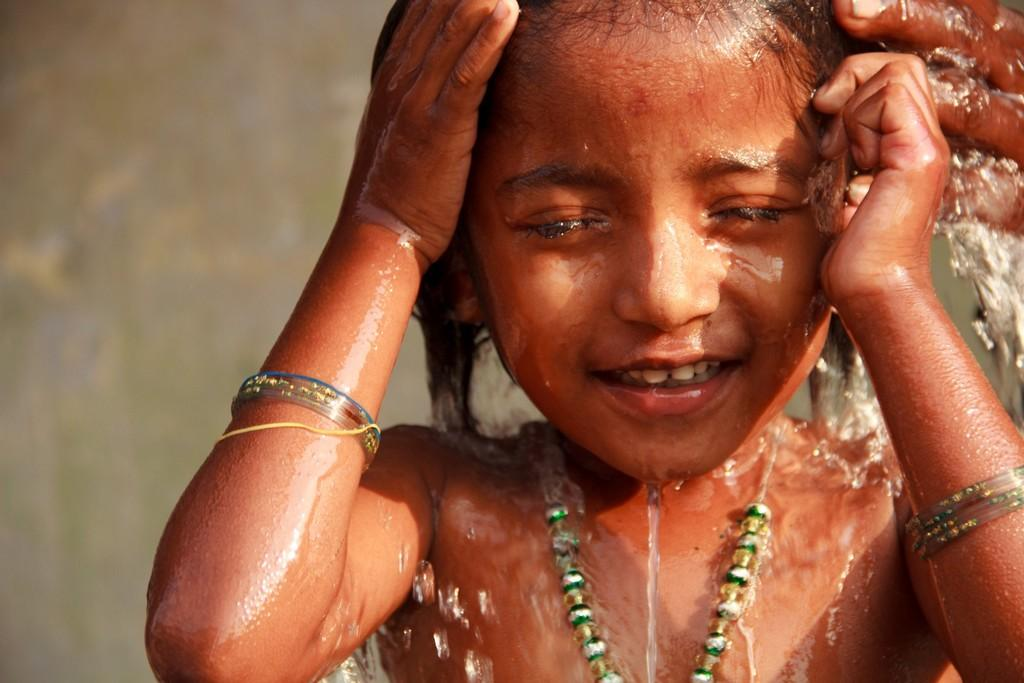Who is the main subject in the image? There is a girl in the image. What is the girl doing in the image? The girl is having a bath. What accessories is the girl wearing in the image? The girl is wearing a necklace and bangles. What type of chicken is visible in the image? There is no chicken present in the image. 